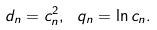Convert formula to latex. <formula><loc_0><loc_0><loc_500><loc_500>d _ { n } = c ^ { 2 } _ { n } , \ q _ { n } = \ln { c _ { n } } .</formula> 